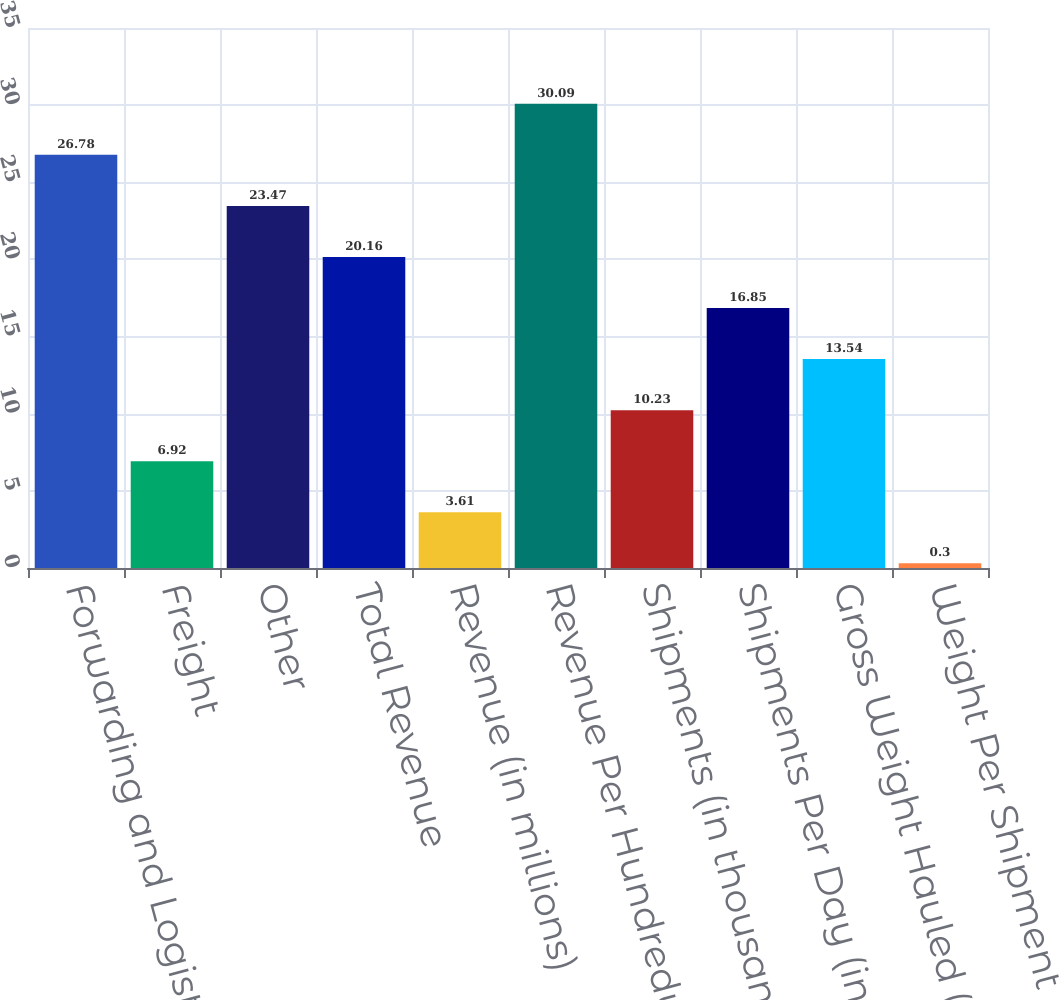Convert chart. <chart><loc_0><loc_0><loc_500><loc_500><bar_chart><fcel>Forwarding and Logistics<fcel>Freight<fcel>Other<fcel>Total Revenue<fcel>Revenue (in millions)<fcel>Revenue Per Hundredweight<fcel>Shipments (in thousands)<fcel>Shipments Per Day (in<fcel>Gross Weight Hauled (in<fcel>Weight Per Shipment (in lbs)<nl><fcel>26.78<fcel>6.92<fcel>23.47<fcel>20.16<fcel>3.61<fcel>30.09<fcel>10.23<fcel>16.85<fcel>13.54<fcel>0.3<nl></chart> 